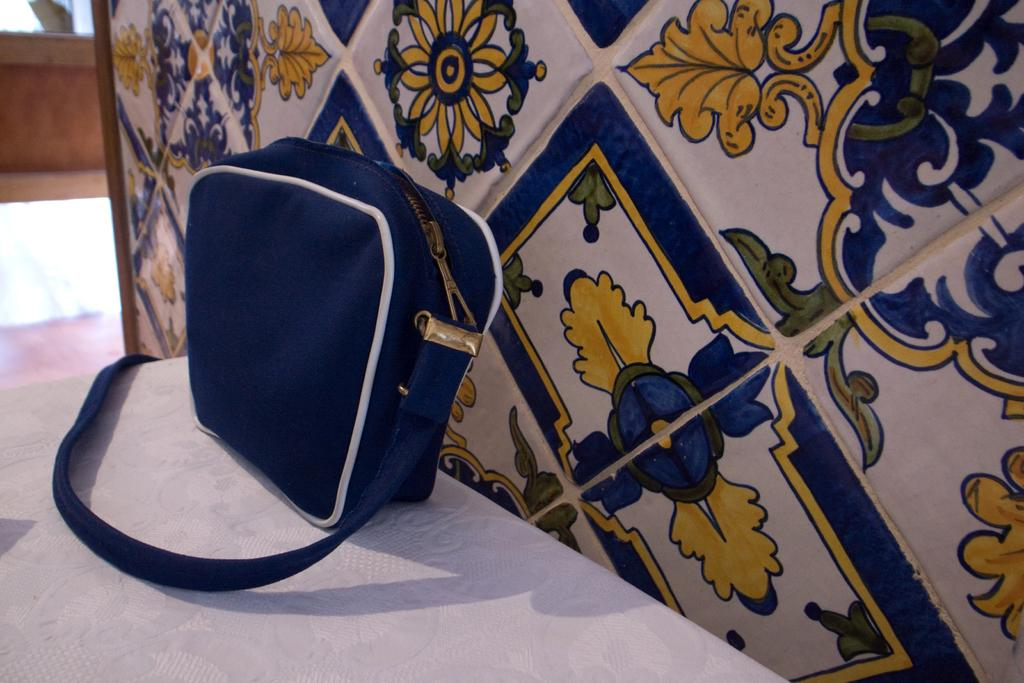What is placed on the table in the image? There is a bag placed on a table. What can be seen in the background of the image? There is a wall with a painting in the background. Is there a squirrel wearing a hat in the image? No, there is no squirrel or hat present in the image. What angle is the painting on the wall displayed at? The angle at which the painting on the wall is displayed cannot be determined from the image. 